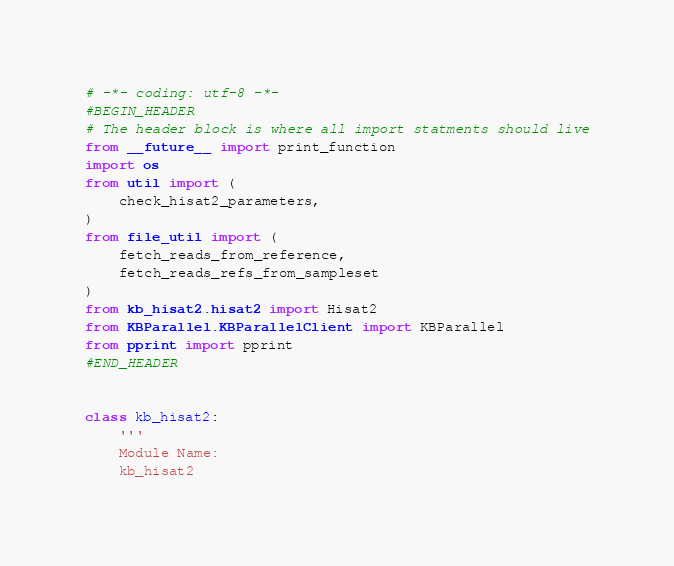Convert code to text. <code><loc_0><loc_0><loc_500><loc_500><_Python_># -*- coding: utf-8 -*-
#BEGIN_HEADER
# The header block is where all import statments should live
from __future__ import print_function
import os
from util import (
    check_hisat2_parameters,
)
from file_util import (
    fetch_reads_from_reference,
    fetch_reads_refs_from_sampleset
)
from kb_hisat2.hisat2 import Hisat2
from KBParallel.KBParallelClient import KBParallel
from pprint import pprint
#END_HEADER


class kb_hisat2:
    '''
    Module Name:
    kb_hisat2
</code> 